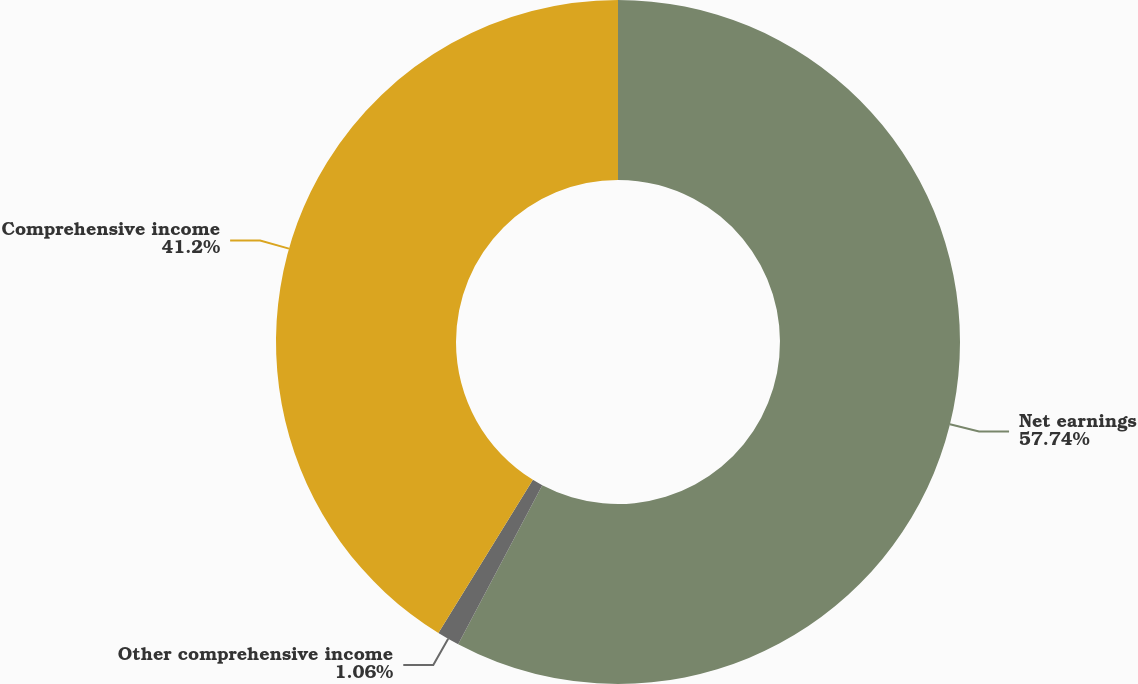Convert chart to OTSL. <chart><loc_0><loc_0><loc_500><loc_500><pie_chart><fcel>Net earnings<fcel>Other comprehensive income<fcel>Comprehensive income<nl><fcel>57.74%<fcel>1.06%<fcel>41.2%<nl></chart> 